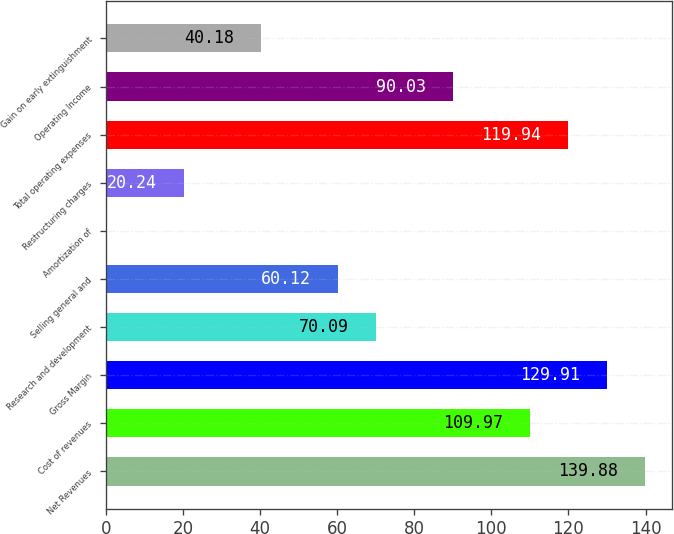Convert chart to OTSL. <chart><loc_0><loc_0><loc_500><loc_500><bar_chart><fcel>Net Revenues<fcel>Cost of revenues<fcel>Gross Margin<fcel>Research and development<fcel>Selling general and<fcel>Amortization of<fcel>Restructuring charges<fcel>Total operating expenses<fcel>Operating Income<fcel>Gain on early extinguishment<nl><fcel>139.88<fcel>109.97<fcel>129.91<fcel>70.09<fcel>60.12<fcel>0.3<fcel>20.24<fcel>119.94<fcel>90.03<fcel>40.18<nl></chart> 